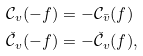<formula> <loc_0><loc_0><loc_500><loc_500>\mathcal { C } _ { v } ( - f ) & = - \mathcal { C } _ { \bar { v } } ( f ) \\ \check { \mathcal { C } } _ { v } ( - f ) & = - \check { \mathcal { C } } _ { v } ( f ) ,</formula> 